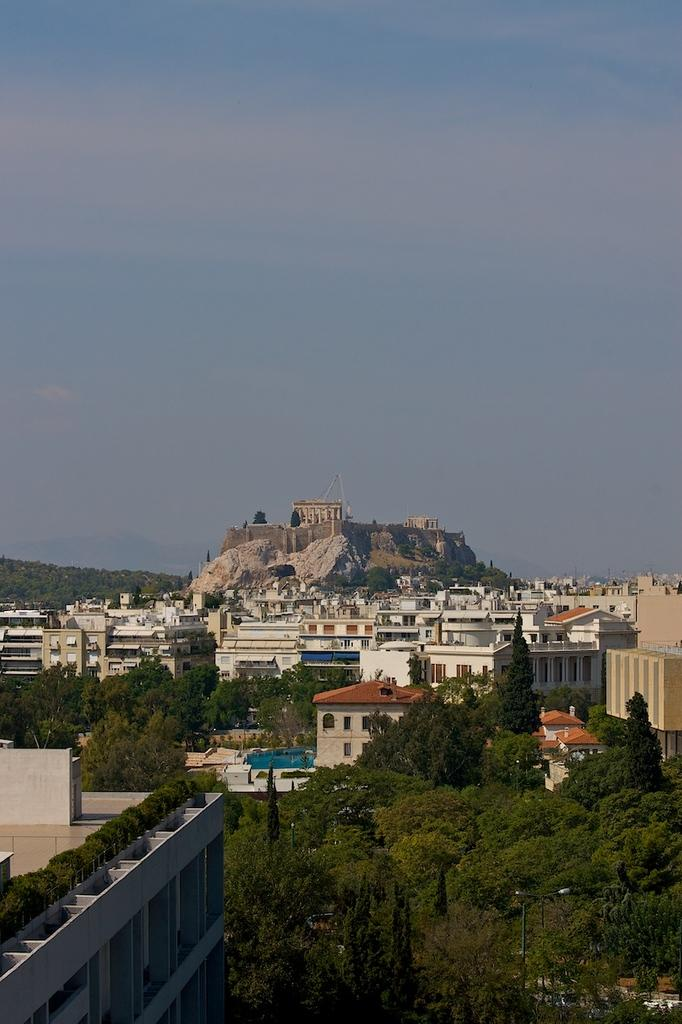What type of view is shown in the image? The image is an aerial view. What type of natural feature can be seen in the image? There are trees in the image. What type of man-made structures are visible in the image? There are houses and buildings in the image. What type of geographical feature can be seen in the image? There is a mountain in the image. How many apples are hanging from the trees in the image? There is no mention of apples in the image; it only shows trees. What unit of currency is used to purchase the houses in the image? There is no information about purchasing houses or currency in the image. 